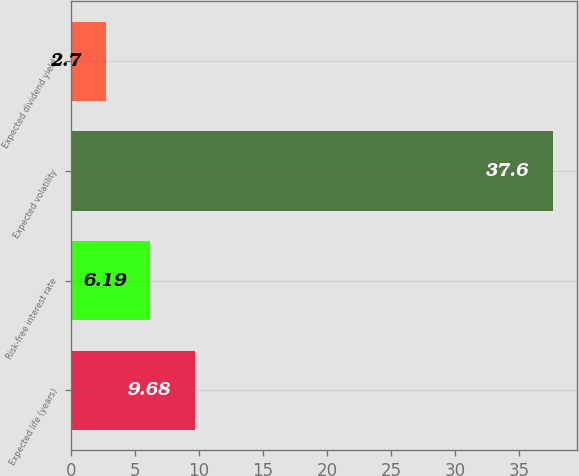Convert chart to OTSL. <chart><loc_0><loc_0><loc_500><loc_500><bar_chart><fcel>Expected life (years)<fcel>Risk-free interest rate<fcel>Expected volatility<fcel>Expected dividend yield<nl><fcel>9.68<fcel>6.19<fcel>37.6<fcel>2.7<nl></chart> 